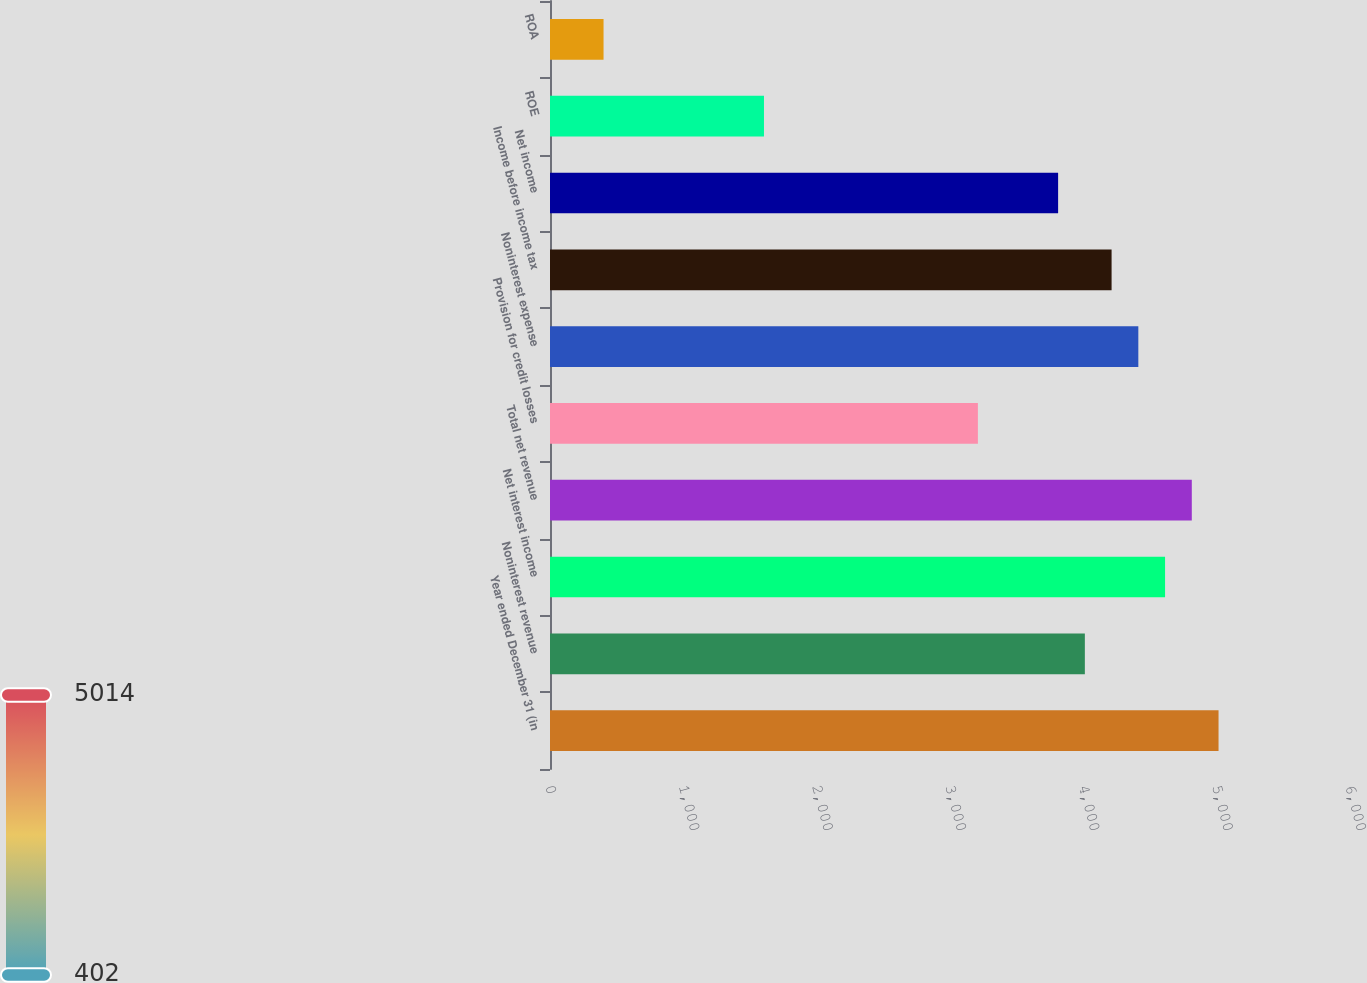Convert chart to OTSL. <chart><loc_0><loc_0><loc_500><loc_500><bar_chart><fcel>Year ended December 31 (in<fcel>Noninterest revenue<fcel>Net interest income<fcel>Total net revenue<fcel>Provision for credit losses<fcel>Noninterest expense<fcel>Income before income tax<fcel>Net income<fcel>ROE<fcel>ROA<nl><fcel>5014.06<fcel>4011.36<fcel>4612.98<fcel>4813.52<fcel>3209.2<fcel>4412.44<fcel>4211.9<fcel>3810.82<fcel>1604.88<fcel>401.64<nl></chart> 